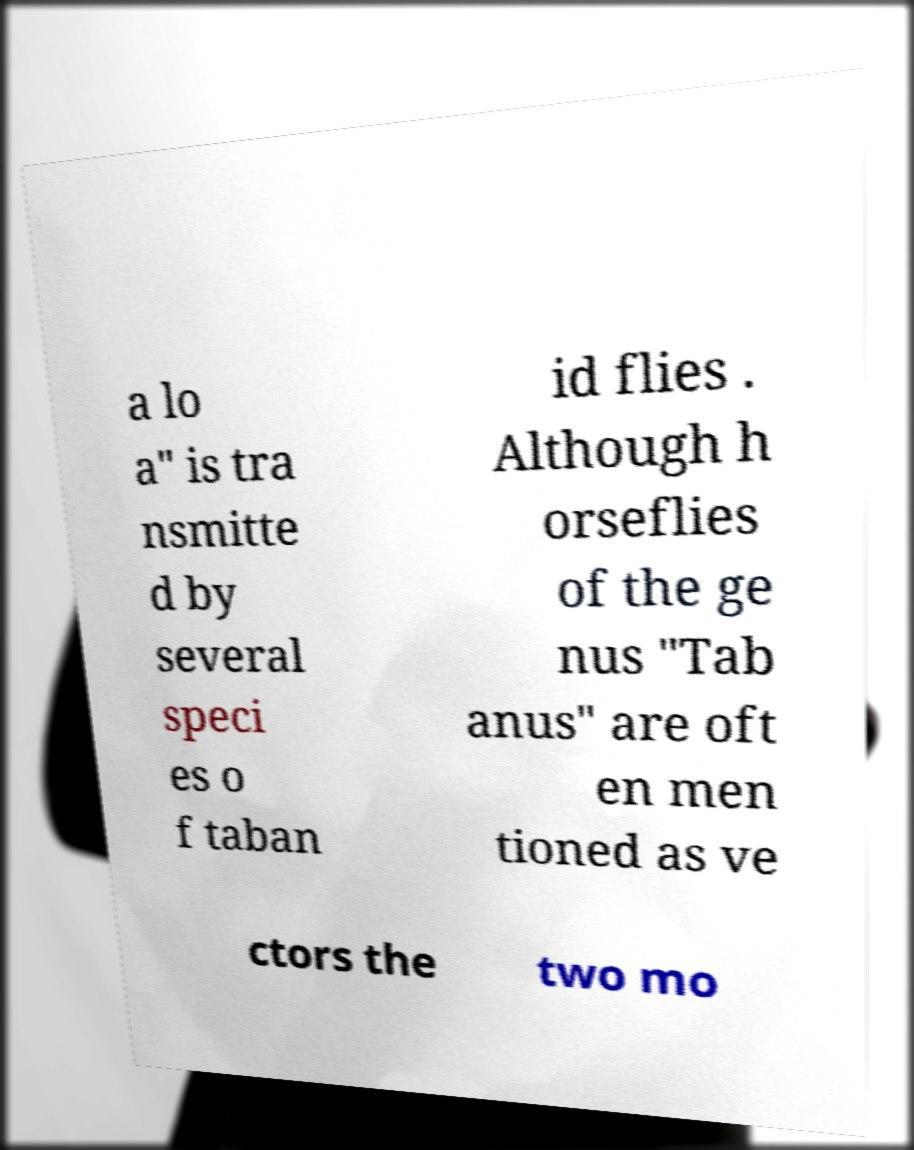Can you accurately transcribe the text from the provided image for me? a lo a" is tra nsmitte d by several speci es o f taban id flies . Although h orseflies of the ge nus "Tab anus" are oft en men tioned as ve ctors the two mo 